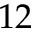Convert formula to latex. <formula><loc_0><loc_0><loc_500><loc_500>1 2</formula> 